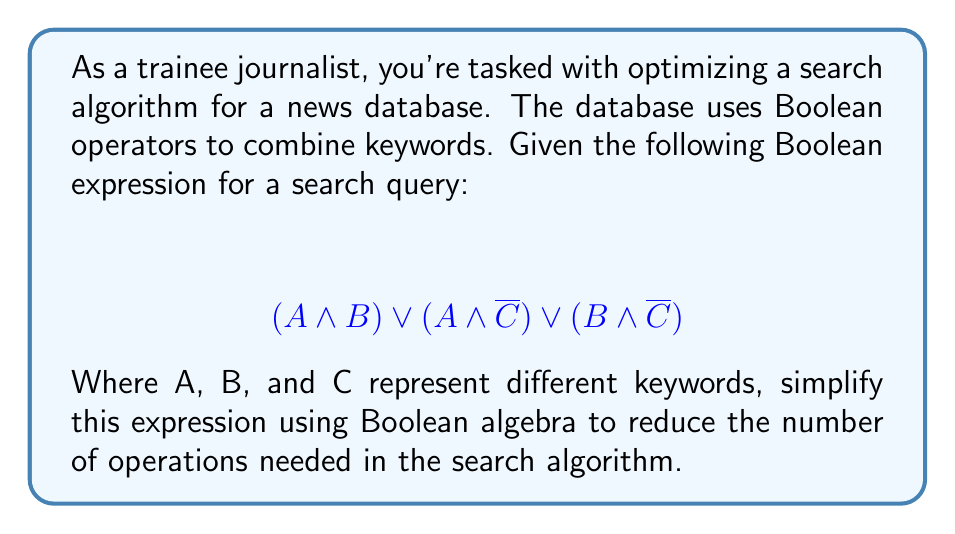Show me your answer to this math problem. Let's simplify this expression step-by-step using Boolean algebra laws:

1) First, we can factor out A from the first two terms:
   $A \land (B \lor \overline{C}) \lor (B \land \overline{C})$

2) Now, we can apply the distributive law to the last term:
   $A \land (B \lor \overline{C}) \lor (B \land \overline{C})$
   $= (A \land B) \lor (A \land \overline{C}) \lor (B \land \overline{C})$

3) We can see that this is our original expression. Let's try a different approach using the absorption law:

4) Absorption law states that $X \lor (X \land Y) = X$

5) In our expression, we can see that $(A \land B)$ and $(A \land \overline{C})$ can absorb $(B \land \overline{C})$:
   $(A \land B) \lor (A \land \overline{C}) \lor (B \land \overline{C})$
   $= (A \land B) \lor (A \land \overline{C})$

6) Now we can factor out A:
   $A \land (B \lor \overline{C})$

This simplified expression reduces the number of operations from 5 (3 AND operations and 2 OR operations) to 2 (1 AND operation and 1 OR operation).
Answer: $A \land (B \lor \overline{C})$ 